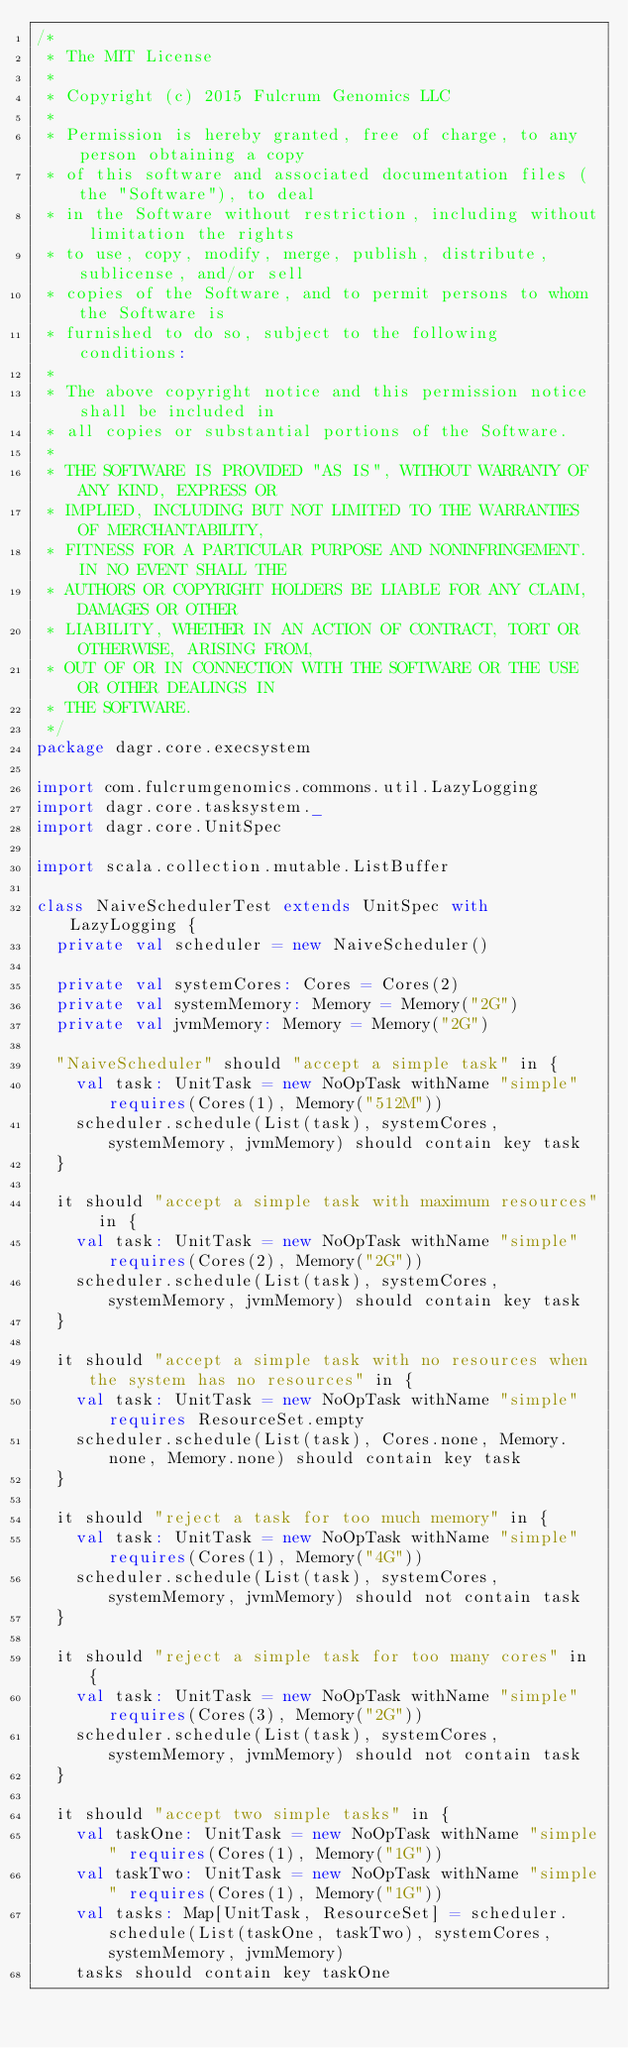<code> <loc_0><loc_0><loc_500><loc_500><_Scala_>/*
 * The MIT License
 *
 * Copyright (c) 2015 Fulcrum Genomics LLC
 *
 * Permission is hereby granted, free of charge, to any person obtaining a copy
 * of this software and associated documentation files (the "Software"), to deal
 * in the Software without restriction, including without limitation the rights
 * to use, copy, modify, merge, publish, distribute, sublicense, and/or sell
 * copies of the Software, and to permit persons to whom the Software is
 * furnished to do so, subject to the following conditions:
 *
 * The above copyright notice and this permission notice shall be included in
 * all copies or substantial portions of the Software.
 *
 * THE SOFTWARE IS PROVIDED "AS IS", WITHOUT WARRANTY OF ANY KIND, EXPRESS OR
 * IMPLIED, INCLUDING BUT NOT LIMITED TO THE WARRANTIES OF MERCHANTABILITY,
 * FITNESS FOR A PARTICULAR PURPOSE AND NONINFRINGEMENT. IN NO EVENT SHALL THE
 * AUTHORS OR COPYRIGHT HOLDERS BE LIABLE FOR ANY CLAIM, DAMAGES OR OTHER
 * LIABILITY, WHETHER IN AN ACTION OF CONTRACT, TORT OR OTHERWISE, ARISING FROM,
 * OUT OF OR IN CONNECTION WITH THE SOFTWARE OR THE USE OR OTHER DEALINGS IN
 * THE SOFTWARE.
 */
package dagr.core.execsystem

import com.fulcrumgenomics.commons.util.LazyLogging
import dagr.core.tasksystem._
import dagr.core.UnitSpec

import scala.collection.mutable.ListBuffer

class NaiveSchedulerTest extends UnitSpec with LazyLogging {
  private val scheduler = new NaiveScheduler()

  private val systemCores: Cores = Cores(2)
  private val systemMemory: Memory = Memory("2G")
  private val jvmMemory: Memory = Memory("2G")

  "NaiveScheduler" should "accept a simple task" in {
    val task: UnitTask = new NoOpTask withName "simple" requires(Cores(1), Memory("512M"))
    scheduler.schedule(List(task), systemCores, systemMemory, jvmMemory) should contain key task
  }

  it should "accept a simple task with maximum resources" in {
    val task: UnitTask = new NoOpTask withName "simple" requires(Cores(2), Memory("2G"))
    scheduler.schedule(List(task), systemCores, systemMemory, jvmMemory) should contain key task
  }

  it should "accept a simple task with no resources when the system has no resources" in {
    val task: UnitTask = new NoOpTask withName "simple" requires ResourceSet.empty
    scheduler.schedule(List(task), Cores.none, Memory.none, Memory.none) should contain key task
  }

  it should "reject a task for too much memory" in {
    val task: UnitTask = new NoOpTask withName "simple" requires(Cores(1), Memory("4G"))
    scheduler.schedule(List(task), systemCores, systemMemory, jvmMemory) should not contain task
  }

  it should "reject a simple task for too many cores" in {
    val task: UnitTask = new NoOpTask withName "simple" requires(Cores(3), Memory("2G"))
    scheduler.schedule(List(task), systemCores, systemMemory, jvmMemory) should not contain task
  }

  it should "accept two simple tasks" in {
    val taskOne: UnitTask = new NoOpTask withName "simple" requires(Cores(1), Memory("1G"))
    val taskTwo: UnitTask = new NoOpTask withName "simple" requires(Cores(1), Memory("1G"))
    val tasks: Map[UnitTask, ResourceSet] = scheduler.schedule(List(taskOne, taskTwo), systemCores, systemMemory, jvmMemory)
    tasks should contain key taskOne</code> 